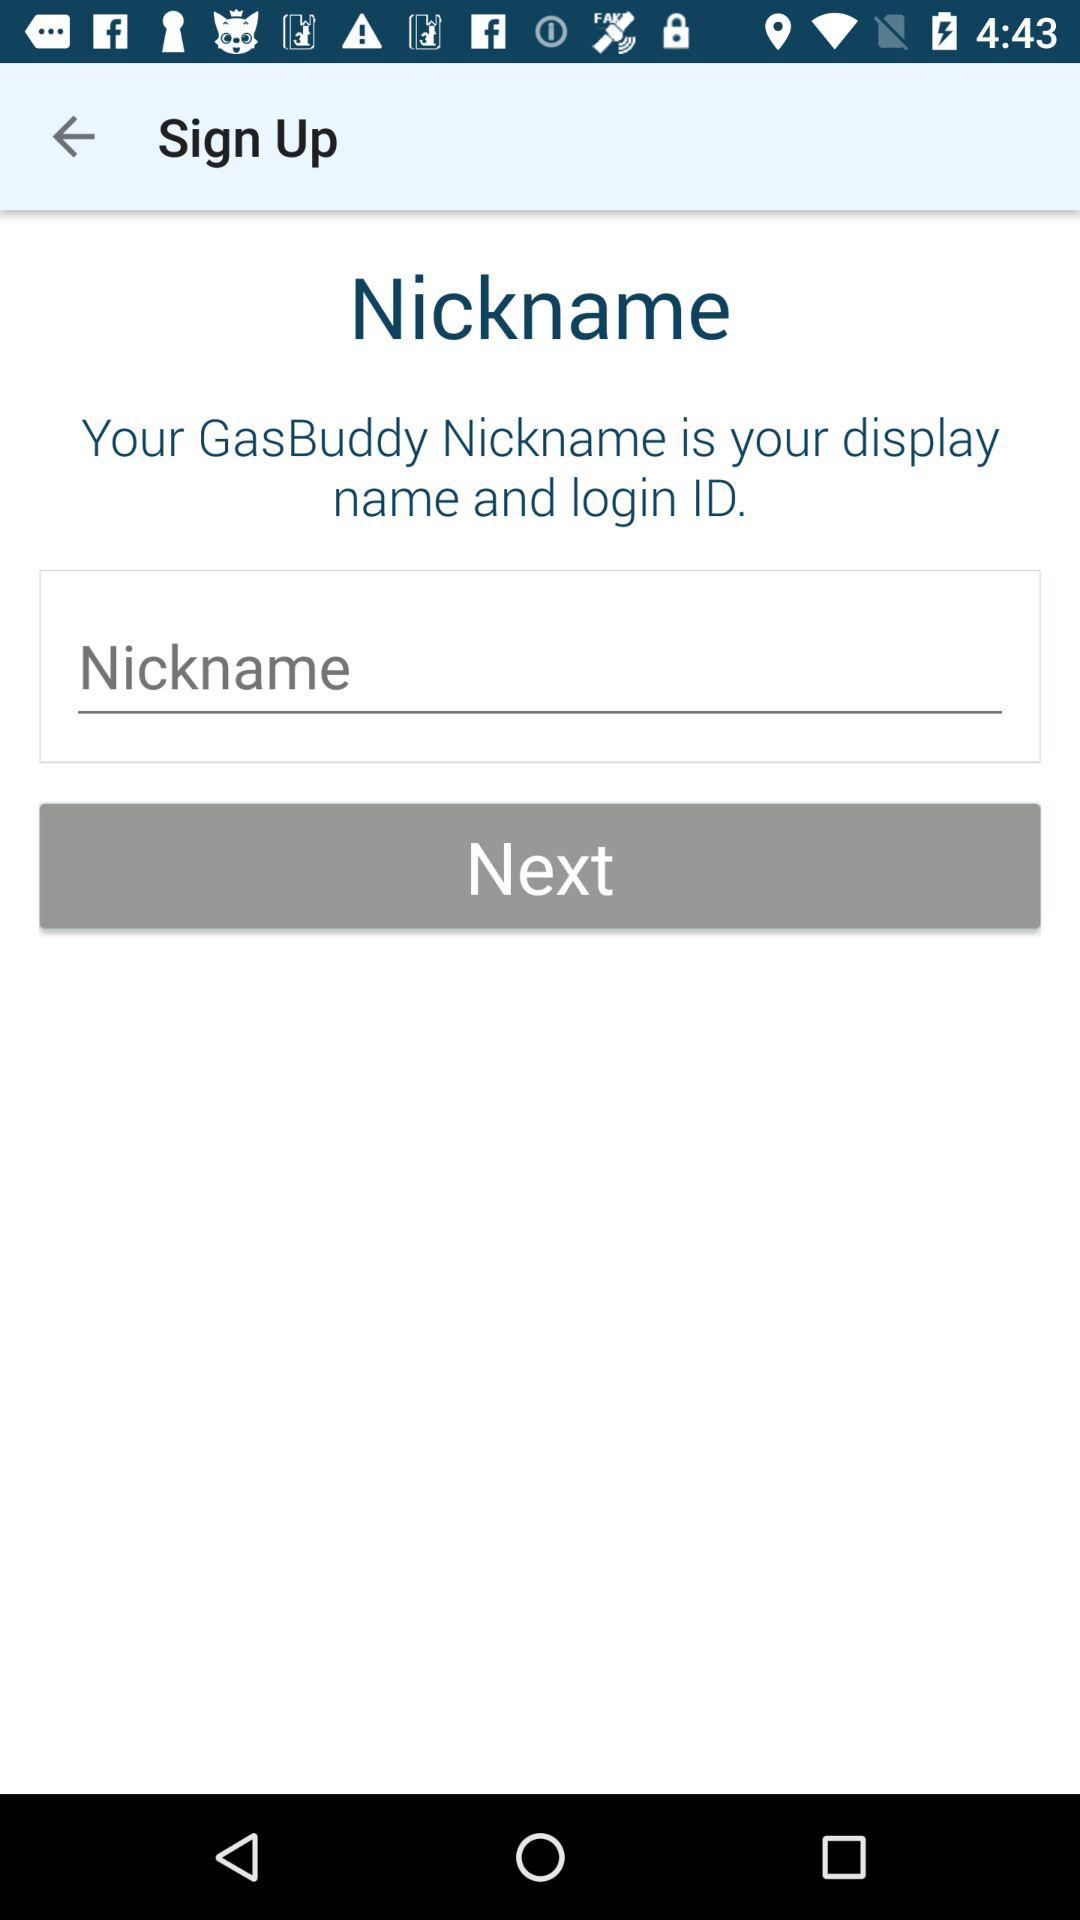What's the Display & Login ID?
When the provided information is insufficient, respond with <no answer>. <no answer> 